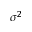Convert formula to latex. <formula><loc_0><loc_0><loc_500><loc_500>\sigma ^ { 2 }</formula> 